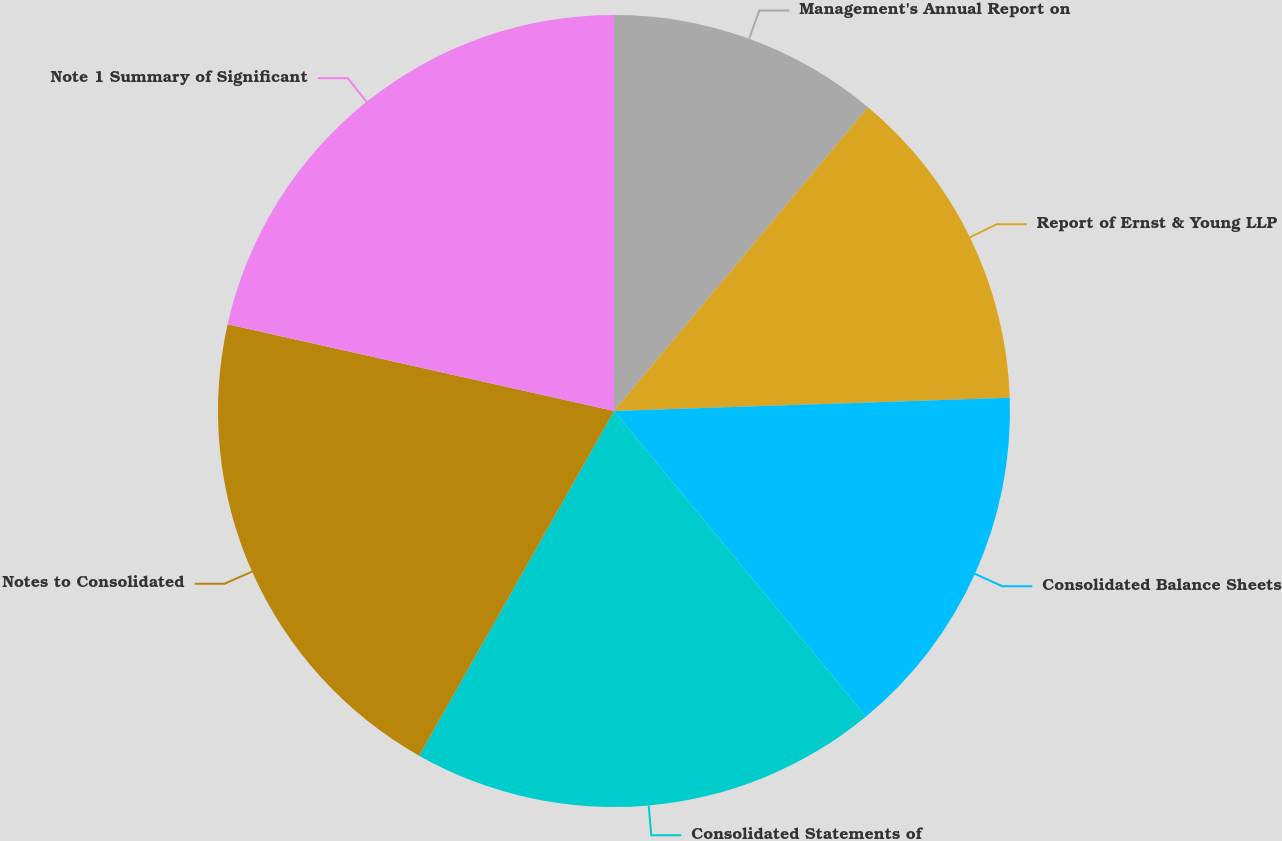<chart> <loc_0><loc_0><loc_500><loc_500><pie_chart><fcel>Management's Annual Report on<fcel>Report of Ernst & Young LLP<fcel>Consolidated Balance Sheets<fcel>Consolidated Statements of<fcel>Notes to Consolidated<fcel>Note 1 Summary of Significant<nl><fcel>11.08%<fcel>13.39%<fcel>14.55%<fcel>19.17%<fcel>20.33%<fcel>21.48%<nl></chart> 